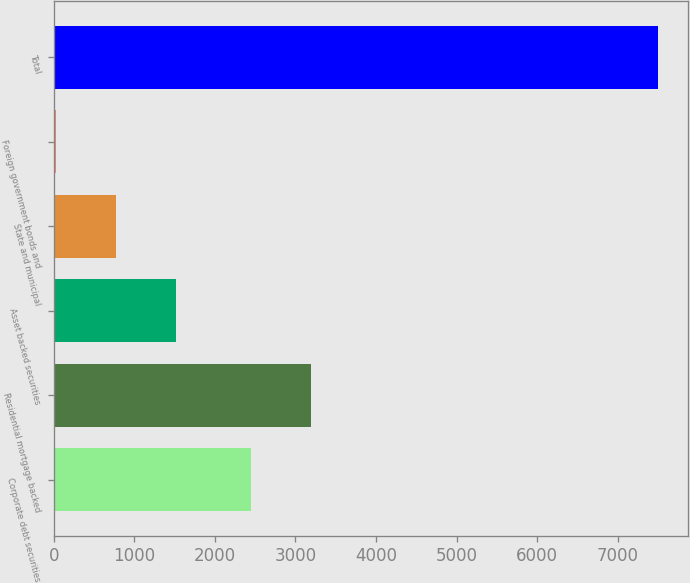Convert chart. <chart><loc_0><loc_0><loc_500><loc_500><bar_chart><fcel>Corporate debt securities<fcel>Residential mortgage backed<fcel>Asset backed securities<fcel>State and municipal<fcel>Foreign government bonds and<fcel>Total<nl><fcel>2452<fcel>3198.6<fcel>1523.2<fcel>776.6<fcel>30<fcel>7496<nl></chart> 